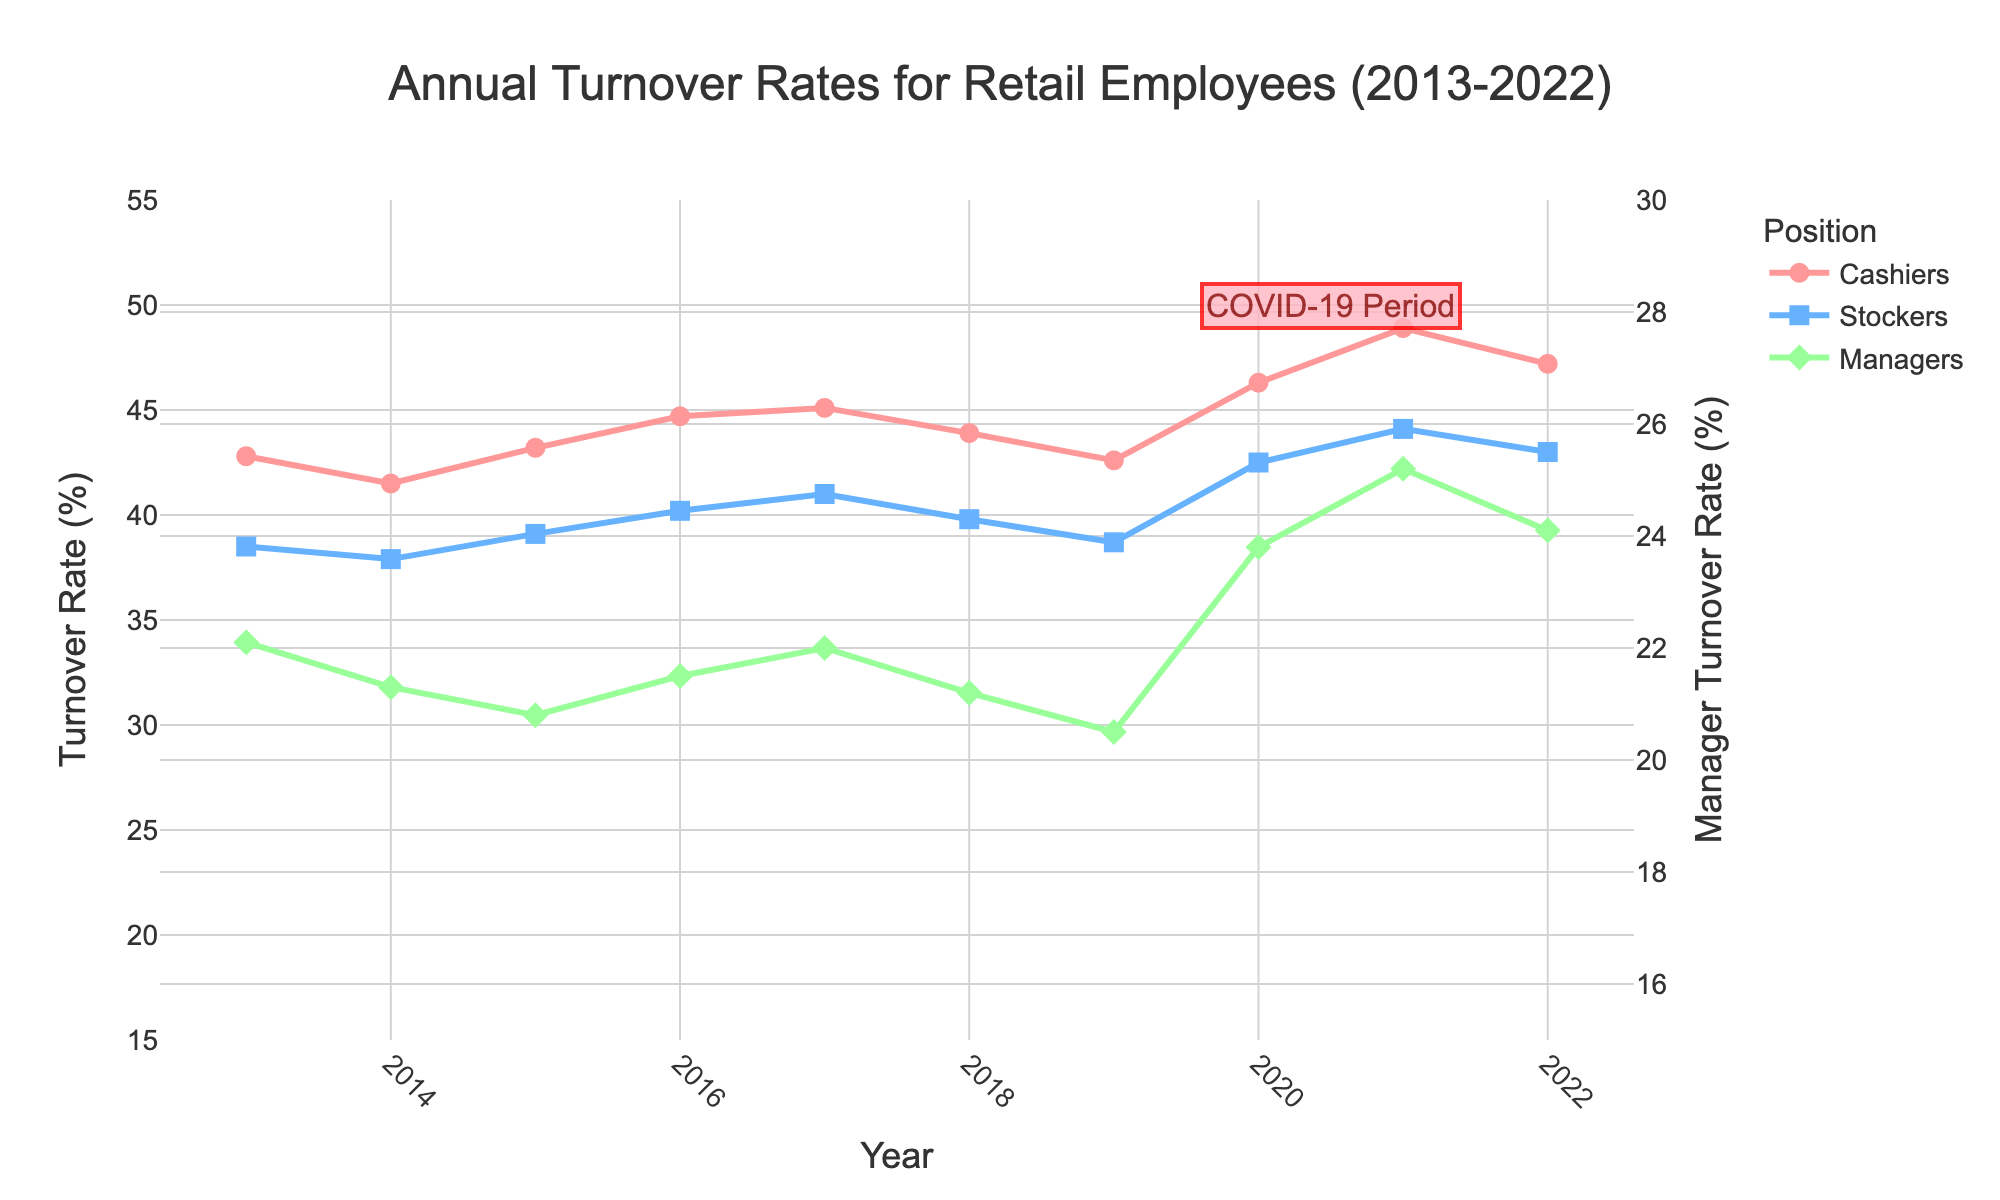What is the turnover rate for stockers in 2020? Look for the value associated with stockers for the year 2020 in the graph.
Answer: 42.5% How did the turnover rates for cashiers change from 2013 to 2022? Identify the turnover rates for cashiers in 2013 and 2022 from the graph and calculate the difference between the two values.
Answer: Increased by 4.4% Which position had the highest turnover rate in 2021? Compare the turnover rates for cashiers, stockers, and managers in 2021 and identify the highest value.
Answer: Cashiers What was the trend in the turnover rate for managers from 2015 to 2018? Look at the data points for managers from 2015 to 2018 and describe whether the values are increasing, decreasing, or maintaining a trend.
Answer: Decreasing trend By how much did the stockers' turnover rate increase between 2019 and 2021? Find the turnover rates for stockers in 2019 and 2021 and calculate the difference.
Answer: 5.4% Between 2013 and 2022, which position experienced the smallest increase in turnover rate? Calculate the increase in turnover rates from 2013 to 2022 for each position and identify the smallest increase.
Answer: Managers What was the turnover rate for cashiers during the COVID-19 Period, according to the graph? Look at the values for cashiers highlighted during the COVID-19 period (2019.5 to 2021.5).
Answer: Around 46.3% - 48.9% In which year did the turnover rate for stockers first exceed 40%? Find the first year in the graph where the turnover rate for stockers is above 40%.
Answer: 2016 What is the overall trend in managers' turnover rates over the decade? Identify the general pattern in the turnover rates for managers from 2013 to 2022.
Answer: Slightly increasing trend In what year did the cashiers' turnover rate reach its peak according to the figure? Identify the year with the highest turnover rate for cashiers in the figure.
Answer: 2021 